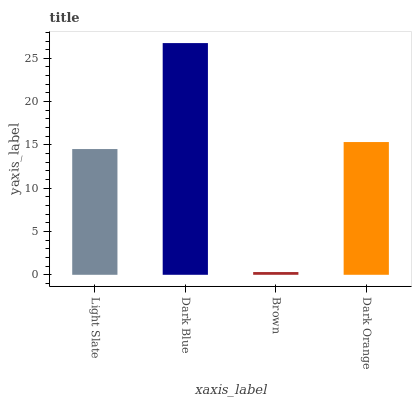Is Brown the minimum?
Answer yes or no. Yes. Is Dark Blue the maximum?
Answer yes or no. Yes. Is Dark Blue the minimum?
Answer yes or no. No. Is Brown the maximum?
Answer yes or no. No. Is Dark Blue greater than Brown?
Answer yes or no. Yes. Is Brown less than Dark Blue?
Answer yes or no. Yes. Is Brown greater than Dark Blue?
Answer yes or no. No. Is Dark Blue less than Brown?
Answer yes or no. No. Is Dark Orange the high median?
Answer yes or no. Yes. Is Light Slate the low median?
Answer yes or no. Yes. Is Brown the high median?
Answer yes or no. No. Is Dark Blue the low median?
Answer yes or no. No. 